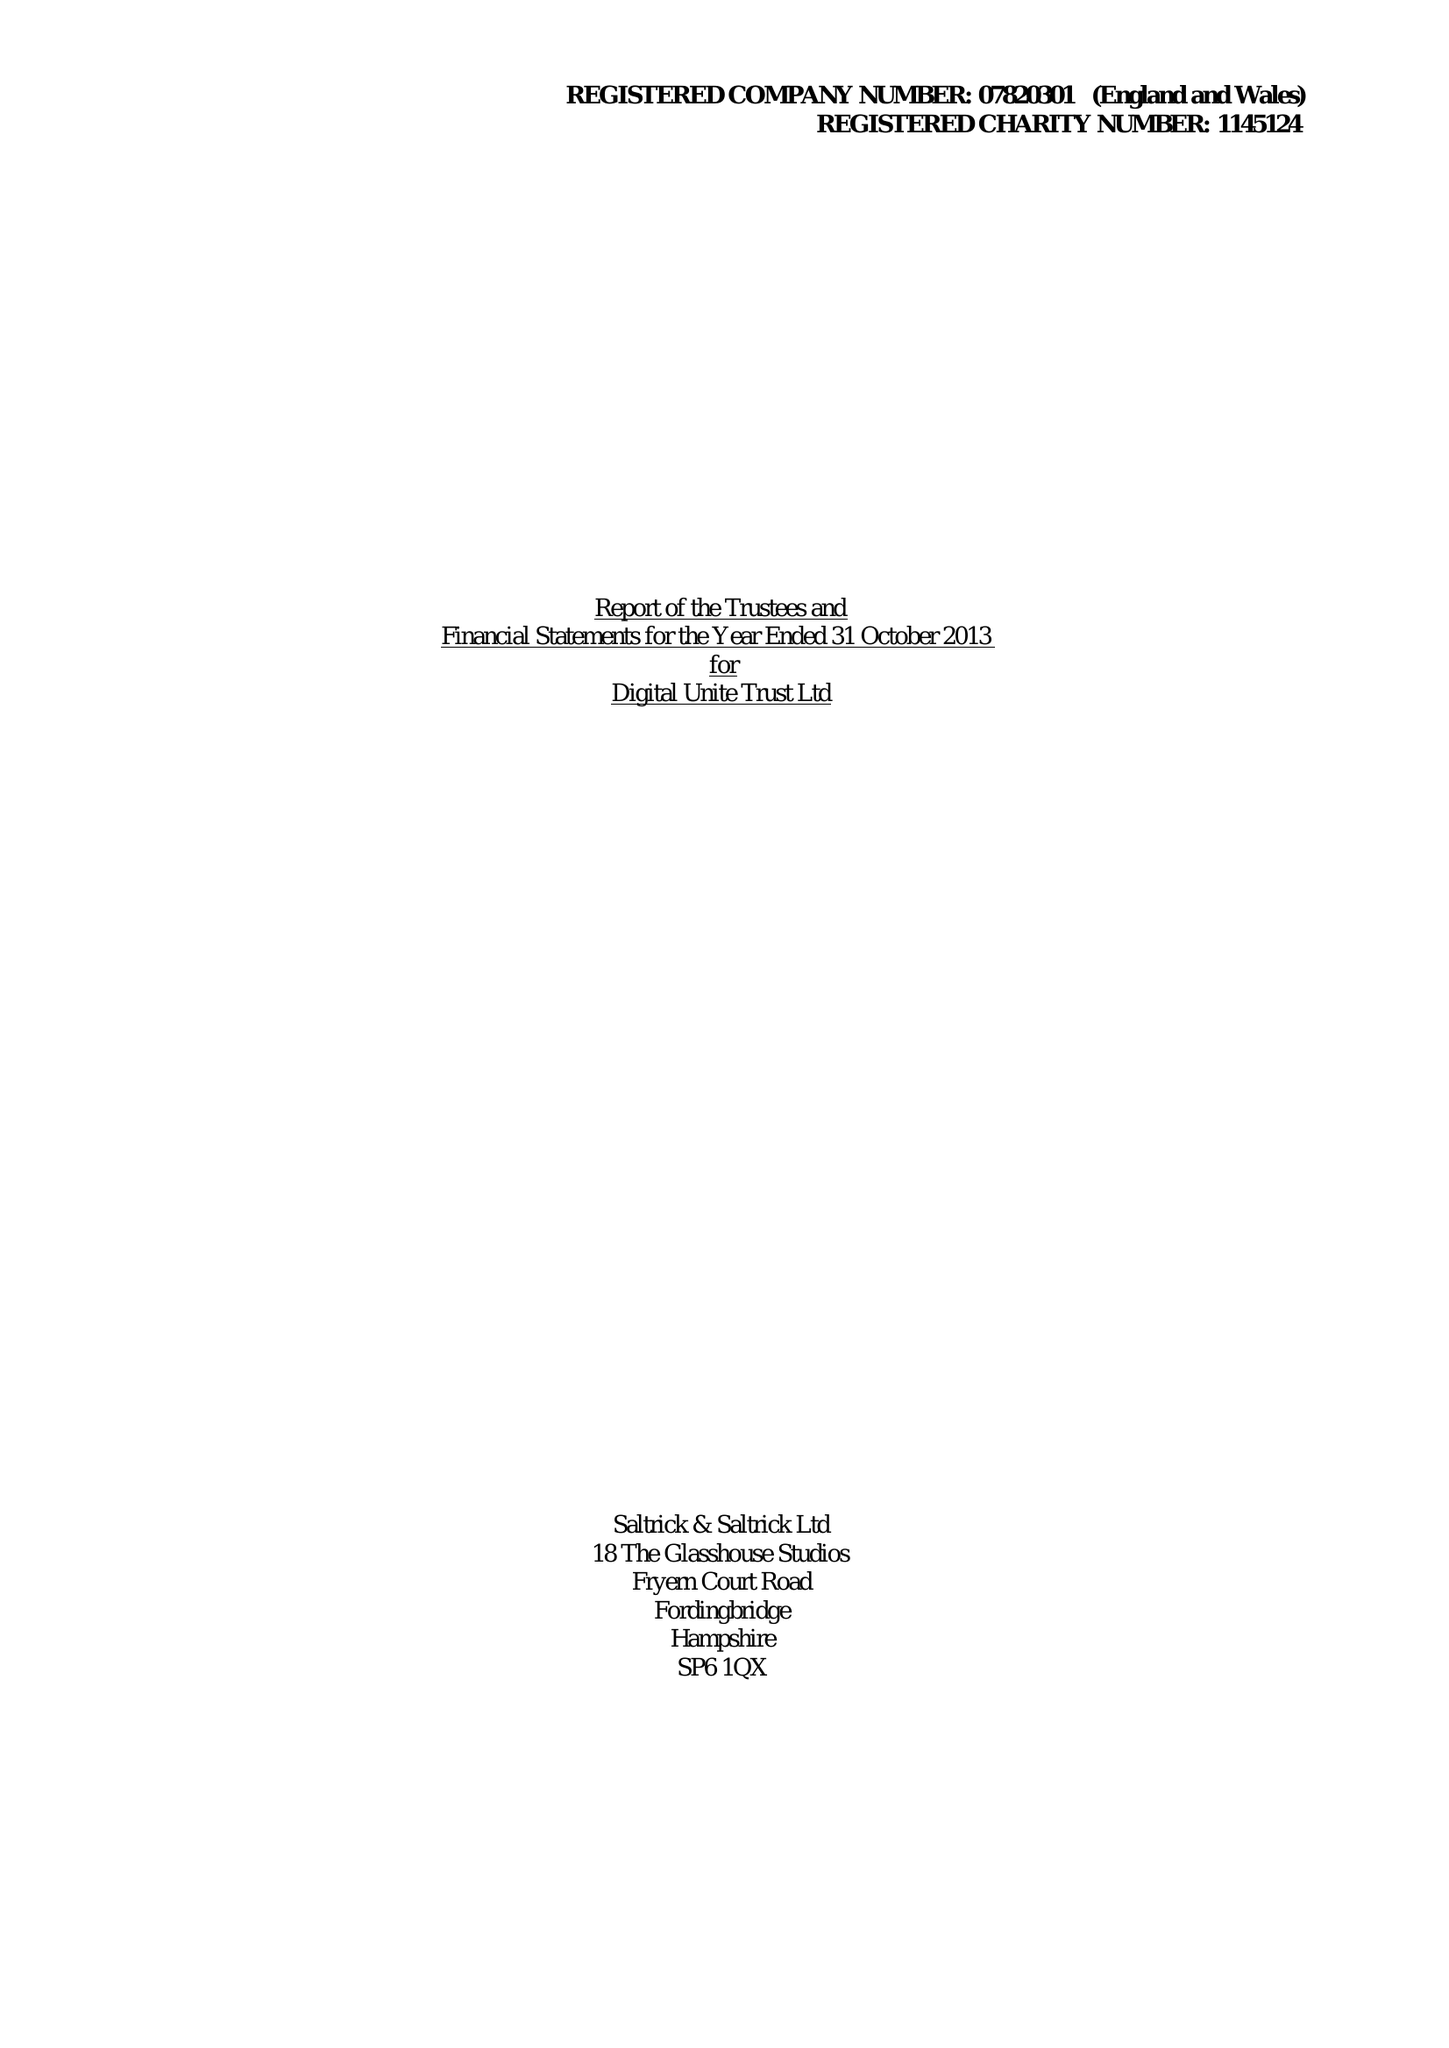What is the value for the spending_annually_in_british_pounds?
Answer the question using a single word or phrase. 61512.00 